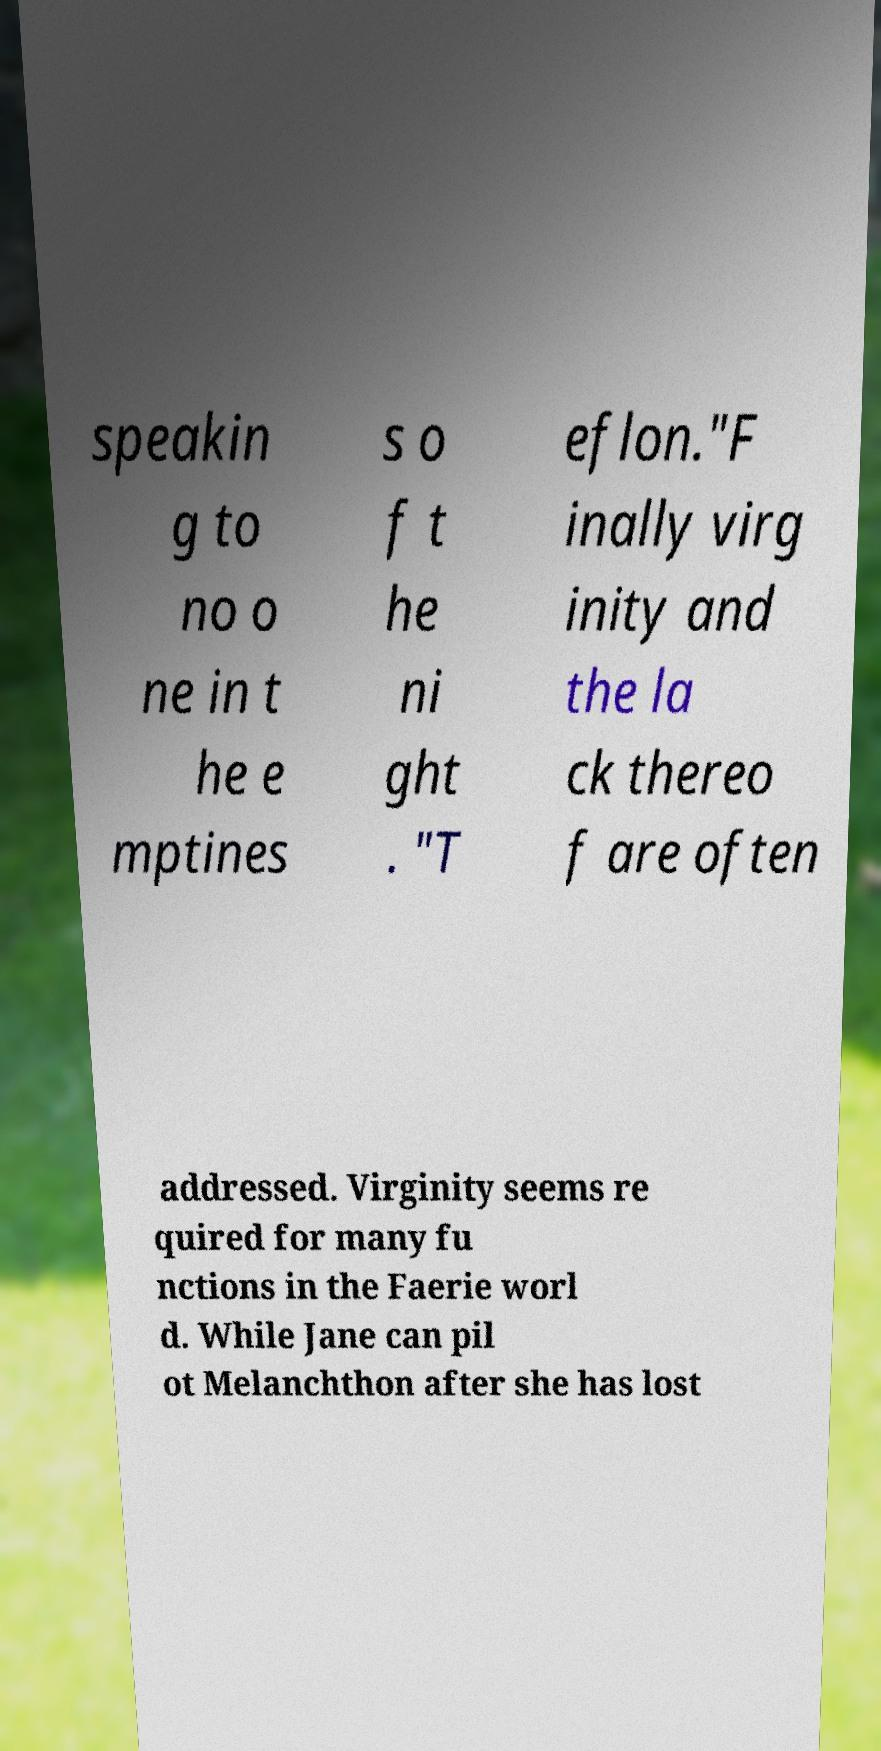Can you read and provide the text displayed in the image?This photo seems to have some interesting text. Can you extract and type it out for me? speakin g to no o ne in t he e mptines s o f t he ni ght . "T eflon."F inally virg inity and the la ck thereo f are often addressed. Virginity seems re quired for many fu nctions in the Faerie worl d. While Jane can pil ot Melanchthon after she has lost 